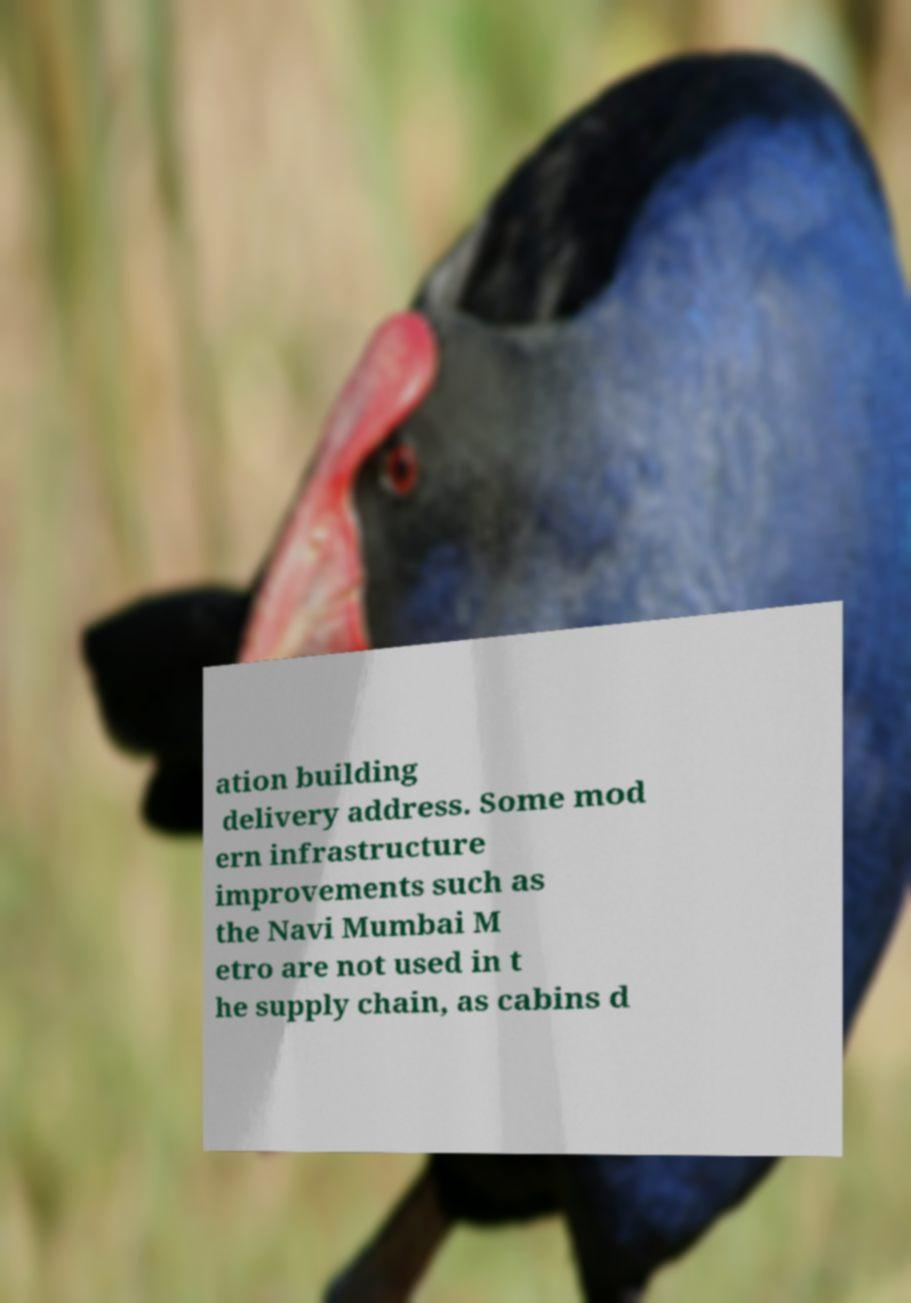What messages or text are displayed in this image? I need them in a readable, typed format. ation building delivery address. Some mod ern infrastructure improvements such as the Navi Mumbai M etro are not used in t he supply chain, as cabins d 